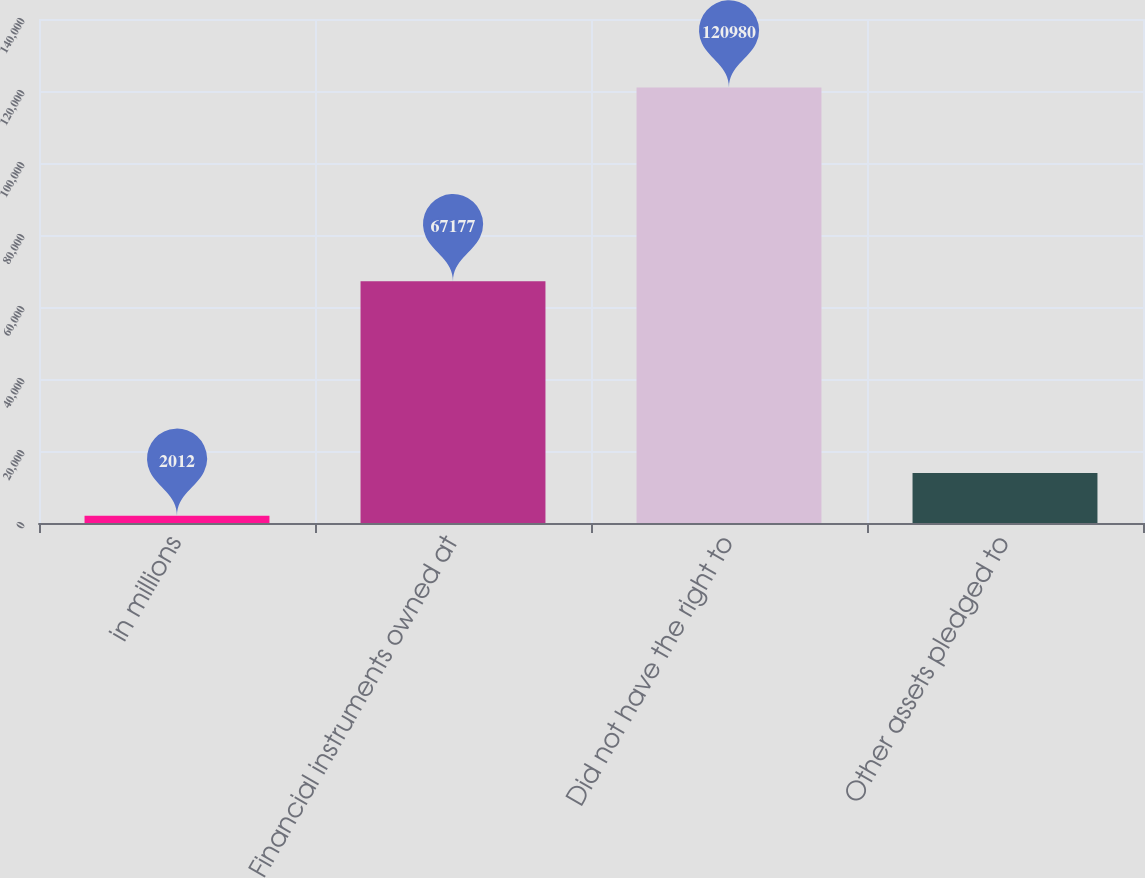Convert chart to OTSL. <chart><loc_0><loc_0><loc_500><loc_500><bar_chart><fcel>in millions<fcel>Financial instruments owned at<fcel>Did not have the right to<fcel>Other assets pledged to<nl><fcel>2012<fcel>67177<fcel>120980<fcel>13908.8<nl></chart> 